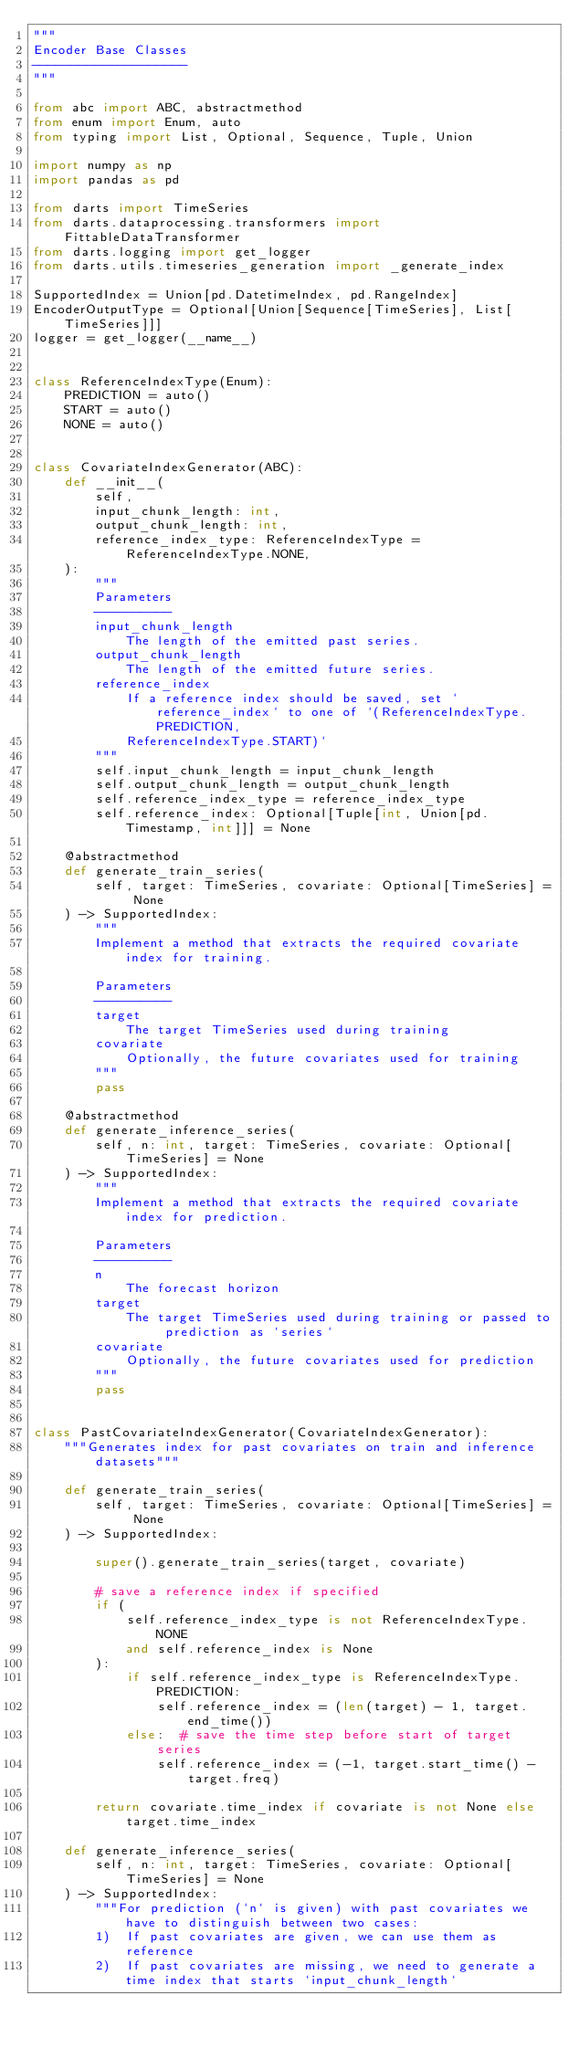Convert code to text. <code><loc_0><loc_0><loc_500><loc_500><_Python_>"""
Encoder Base Classes
--------------------
"""

from abc import ABC, abstractmethod
from enum import Enum, auto
from typing import List, Optional, Sequence, Tuple, Union

import numpy as np
import pandas as pd

from darts import TimeSeries
from darts.dataprocessing.transformers import FittableDataTransformer
from darts.logging import get_logger
from darts.utils.timeseries_generation import _generate_index

SupportedIndex = Union[pd.DatetimeIndex, pd.RangeIndex]
EncoderOutputType = Optional[Union[Sequence[TimeSeries], List[TimeSeries]]]
logger = get_logger(__name__)


class ReferenceIndexType(Enum):
    PREDICTION = auto()
    START = auto()
    NONE = auto()


class CovariateIndexGenerator(ABC):
    def __init__(
        self,
        input_chunk_length: int,
        output_chunk_length: int,
        reference_index_type: ReferenceIndexType = ReferenceIndexType.NONE,
    ):
        """
        Parameters
        ----------
        input_chunk_length
            The length of the emitted past series.
        output_chunk_length
            The length of the emitted future series.
        reference_index
            If a reference index should be saved, set `reference_index` to one of `(ReferenceIndexType.PREDICTION,
            ReferenceIndexType.START)`
        """
        self.input_chunk_length = input_chunk_length
        self.output_chunk_length = output_chunk_length
        self.reference_index_type = reference_index_type
        self.reference_index: Optional[Tuple[int, Union[pd.Timestamp, int]]] = None

    @abstractmethod
    def generate_train_series(
        self, target: TimeSeries, covariate: Optional[TimeSeries] = None
    ) -> SupportedIndex:
        """
        Implement a method that extracts the required covariate index for training.

        Parameters
        ----------
        target
            The target TimeSeries used during training
        covariate
            Optionally, the future covariates used for training
        """
        pass

    @abstractmethod
    def generate_inference_series(
        self, n: int, target: TimeSeries, covariate: Optional[TimeSeries] = None
    ) -> SupportedIndex:
        """
        Implement a method that extracts the required covariate index for prediction.

        Parameters
        ----------
        n
            The forecast horizon
        target
            The target TimeSeries used during training or passed to prediction as `series`
        covariate
            Optionally, the future covariates used for prediction
        """
        pass


class PastCovariateIndexGenerator(CovariateIndexGenerator):
    """Generates index for past covariates on train and inference datasets"""

    def generate_train_series(
        self, target: TimeSeries, covariate: Optional[TimeSeries] = None
    ) -> SupportedIndex:

        super().generate_train_series(target, covariate)

        # save a reference index if specified
        if (
            self.reference_index_type is not ReferenceIndexType.NONE
            and self.reference_index is None
        ):
            if self.reference_index_type is ReferenceIndexType.PREDICTION:
                self.reference_index = (len(target) - 1, target.end_time())
            else:  # save the time step before start of target series
                self.reference_index = (-1, target.start_time() - target.freq)

        return covariate.time_index if covariate is not None else target.time_index

    def generate_inference_series(
        self, n: int, target: TimeSeries, covariate: Optional[TimeSeries] = None
    ) -> SupportedIndex:
        """For prediction (`n` is given) with past covariates we have to distinguish between two cases:
        1)  If past covariates are given, we can use them as reference
        2)  If past covariates are missing, we need to generate a time index that starts `input_chunk_length`</code> 